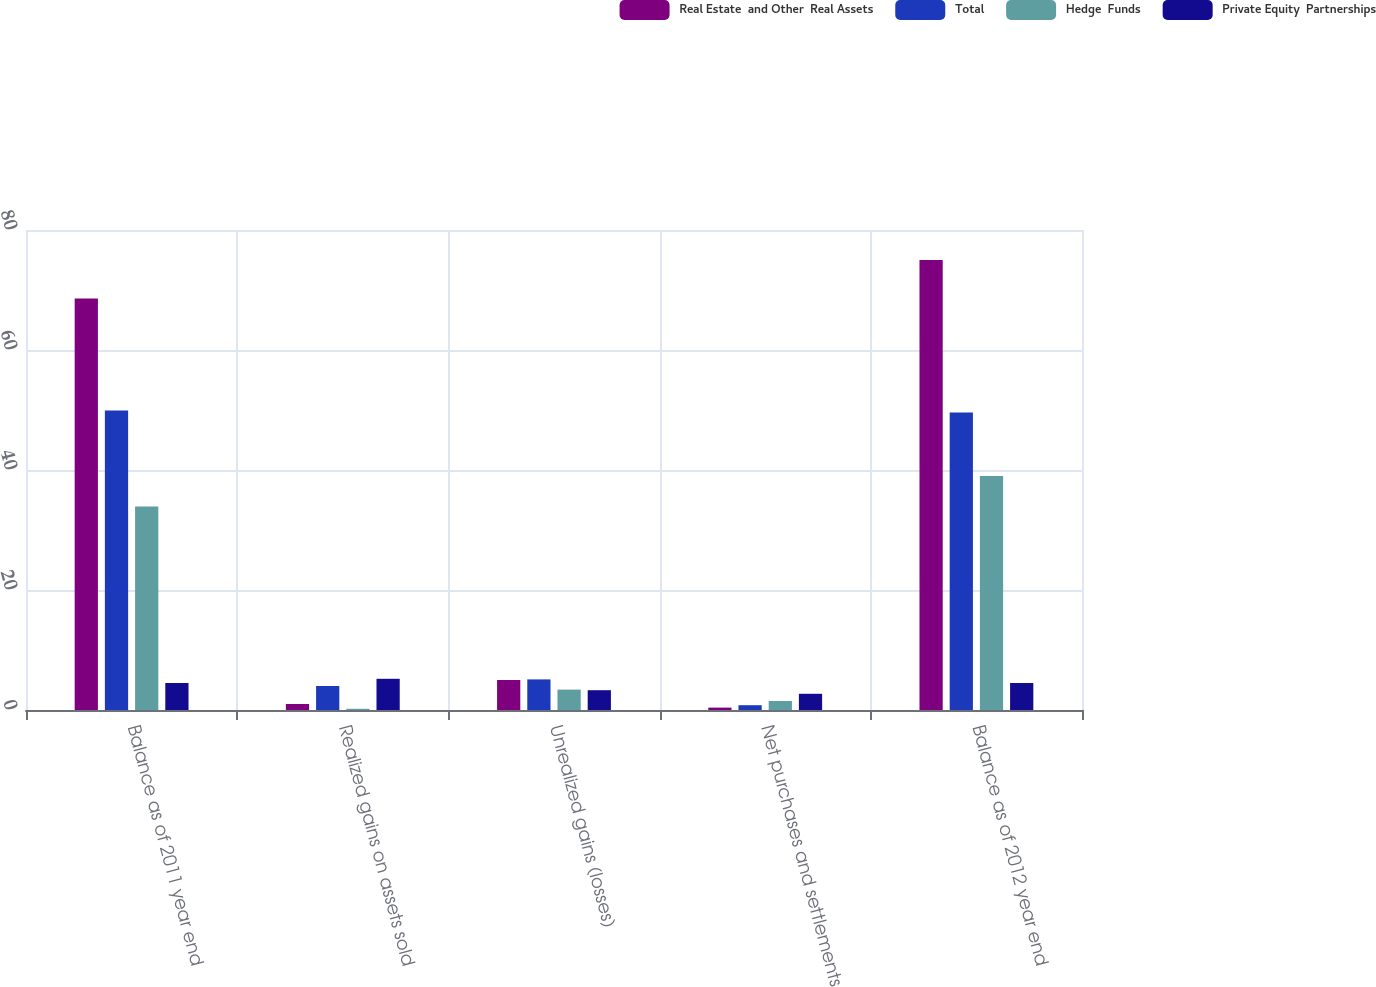Convert chart to OTSL. <chart><loc_0><loc_0><loc_500><loc_500><stacked_bar_chart><ecel><fcel>Balance as of 2011 year end<fcel>Realized gains on assets sold<fcel>Unrealized gains (losses)<fcel>Net purchases and settlements<fcel>Balance as of 2012 year end<nl><fcel>Real Estate  and Other  Real Assets<fcel>68.6<fcel>1<fcel>5<fcel>0.4<fcel>75<nl><fcel>Total<fcel>49.9<fcel>4<fcel>5.1<fcel>0.8<fcel>49.6<nl><fcel>Hedge  Funds<fcel>33.9<fcel>0.2<fcel>3.4<fcel>1.5<fcel>39<nl><fcel>Private Equity  Partnerships<fcel>4.5<fcel>5.2<fcel>3.3<fcel>2.7<fcel>4.5<nl></chart> 